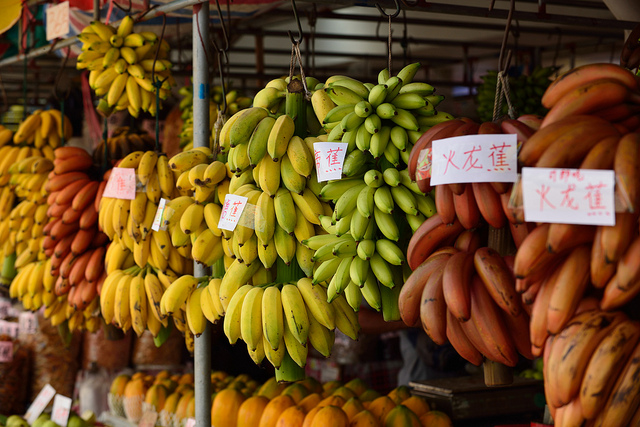<image>How much do the bananas cost? I don't know how much the bananas cost. It is not clearly stated. How much do the bananas cost? It is unknown how much the bananas cost. 